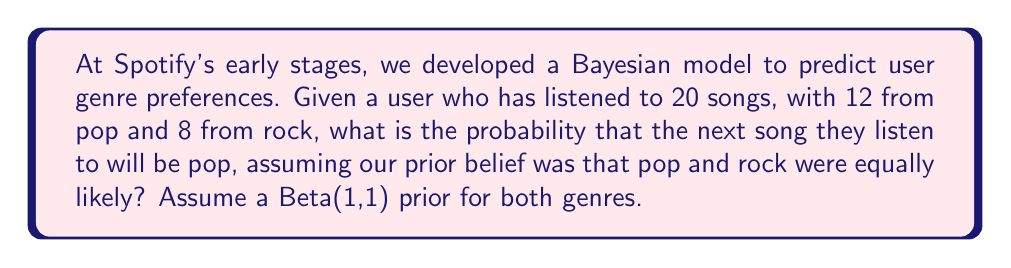Give your solution to this math problem. Let's approach this step-by-step using Bayesian inference:

1) We start with a Beta(1,1) prior for both pop and rock, which is equivalent to a uniform distribution on [0,1].

2) For pop, we observe 12 successes out of 20 trials. The posterior distribution for pop is:
   $$\text{Beta}(1+12, 1+20-12) = \text{Beta}(13, 9)$$

3) For rock, we observe 8 successes out of 20 trials. The posterior distribution for rock is:
   $$\text{Beta}(1+8, 1+20-8) = \text{Beta}(9, 13)$$

4) The probability that the next song will be pop is the expected value of the Beta(13,9) distribution:
   $$E[\text{Beta}(13,9)] = \frac{\alpha}{\alpha + \beta} = \frac{13}{13+9} = \frac{13}{22}$$

5) We can verify this result by calculating the probability for rock:
   $$E[\text{Beta}(9,13)] = \frac{9}{9+13} = \frac{9}{22}$$

   Note that $\frac{13}{22} + \frac{9}{22} = 1$, as expected.

Therefore, the probability that the next song will be pop is $\frac{13}{22}$ or approximately 0.5909.
Answer: $\frac{13}{22}$ 